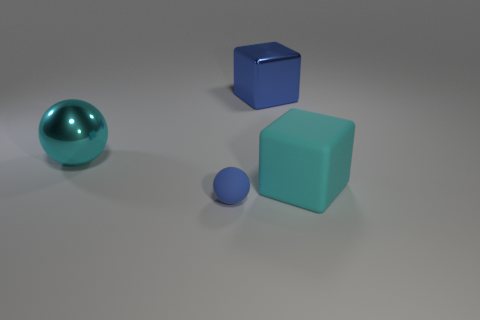There is another thing that is the same color as the big rubber object; what is it made of?
Provide a short and direct response. Metal. How many blue shiny objects are there?
Your answer should be very brief. 1. Are there fewer big brown objects than large cyan shiny objects?
Your answer should be compact. Yes. There is a cyan sphere that is the same size as the shiny block; what is its material?
Offer a very short reply. Metal. What number of objects are big blue rubber cylinders or shiny things?
Give a very brief answer. 2. What number of balls are both in front of the rubber cube and on the left side of the blue sphere?
Provide a short and direct response. 0. Is the number of metal cubes that are in front of the big sphere less than the number of large rubber cubes?
Provide a short and direct response. Yes. There is a cyan shiny thing that is the same size as the cyan matte thing; what is its shape?
Make the answer very short. Sphere. How many other things are there of the same color as the large rubber object?
Your answer should be very brief. 1. Is the rubber sphere the same size as the cyan rubber cube?
Make the answer very short. No. 